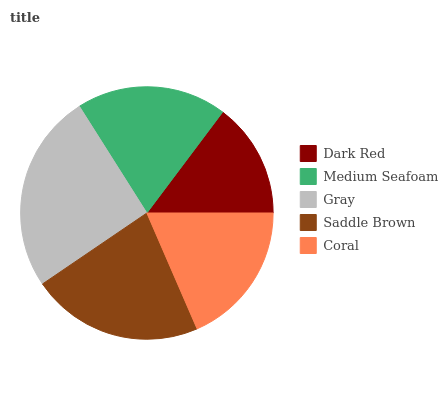Is Dark Red the minimum?
Answer yes or no. Yes. Is Gray the maximum?
Answer yes or no. Yes. Is Medium Seafoam the minimum?
Answer yes or no. No. Is Medium Seafoam the maximum?
Answer yes or no. No. Is Medium Seafoam greater than Dark Red?
Answer yes or no. Yes. Is Dark Red less than Medium Seafoam?
Answer yes or no. Yes. Is Dark Red greater than Medium Seafoam?
Answer yes or no. No. Is Medium Seafoam less than Dark Red?
Answer yes or no. No. Is Medium Seafoam the high median?
Answer yes or no. Yes. Is Medium Seafoam the low median?
Answer yes or no. Yes. Is Coral the high median?
Answer yes or no. No. Is Coral the low median?
Answer yes or no. No. 